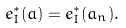Convert formula to latex. <formula><loc_0><loc_0><loc_500><loc_500>e _ { I } ^ { \ast } ( a ) = e _ { I } ^ { \ast } ( a _ { n } ) .</formula> 